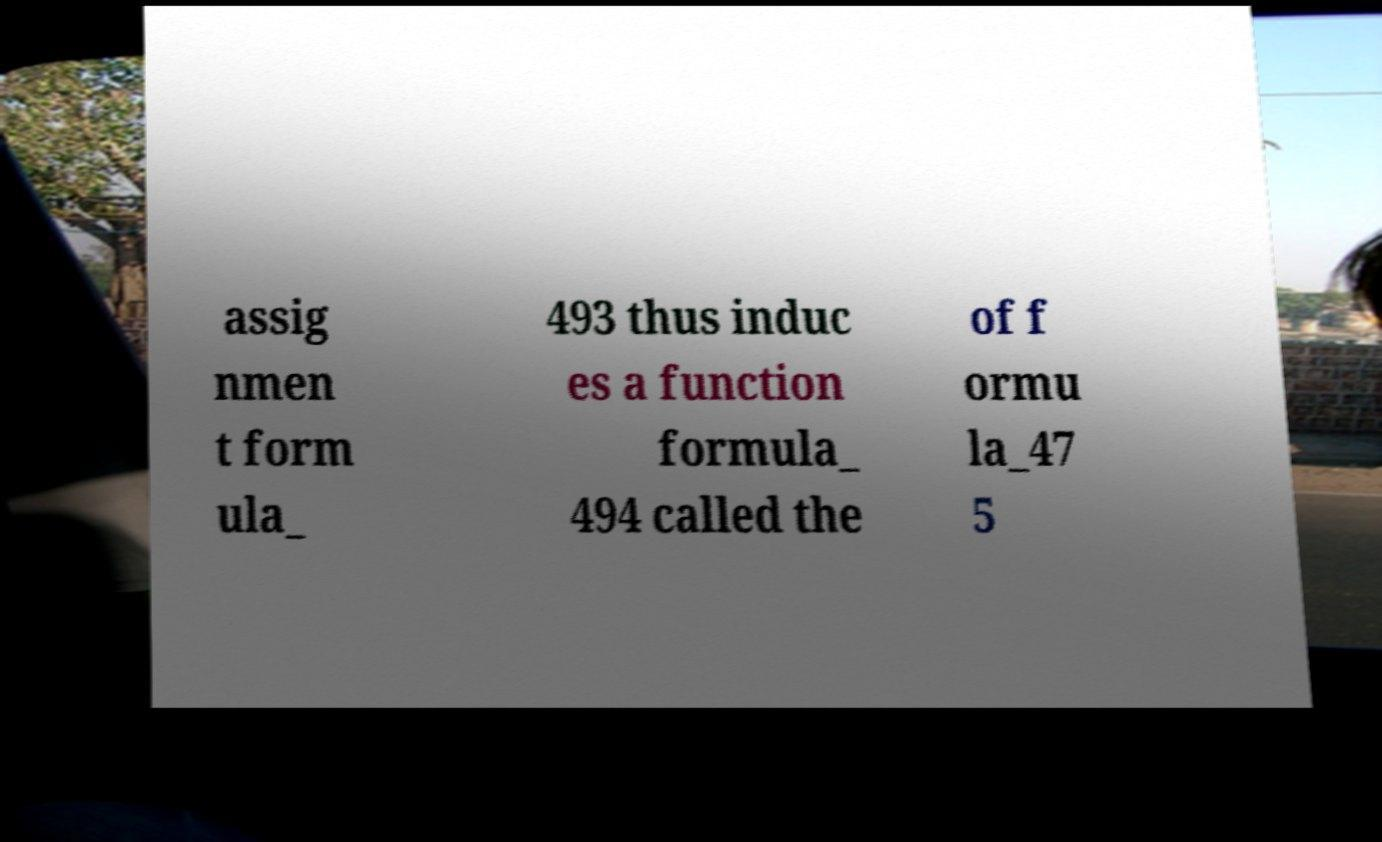Could you extract and type out the text from this image? assig nmen t form ula_ 493 thus induc es a function formula_ 494 called the of f ormu la_47 5 